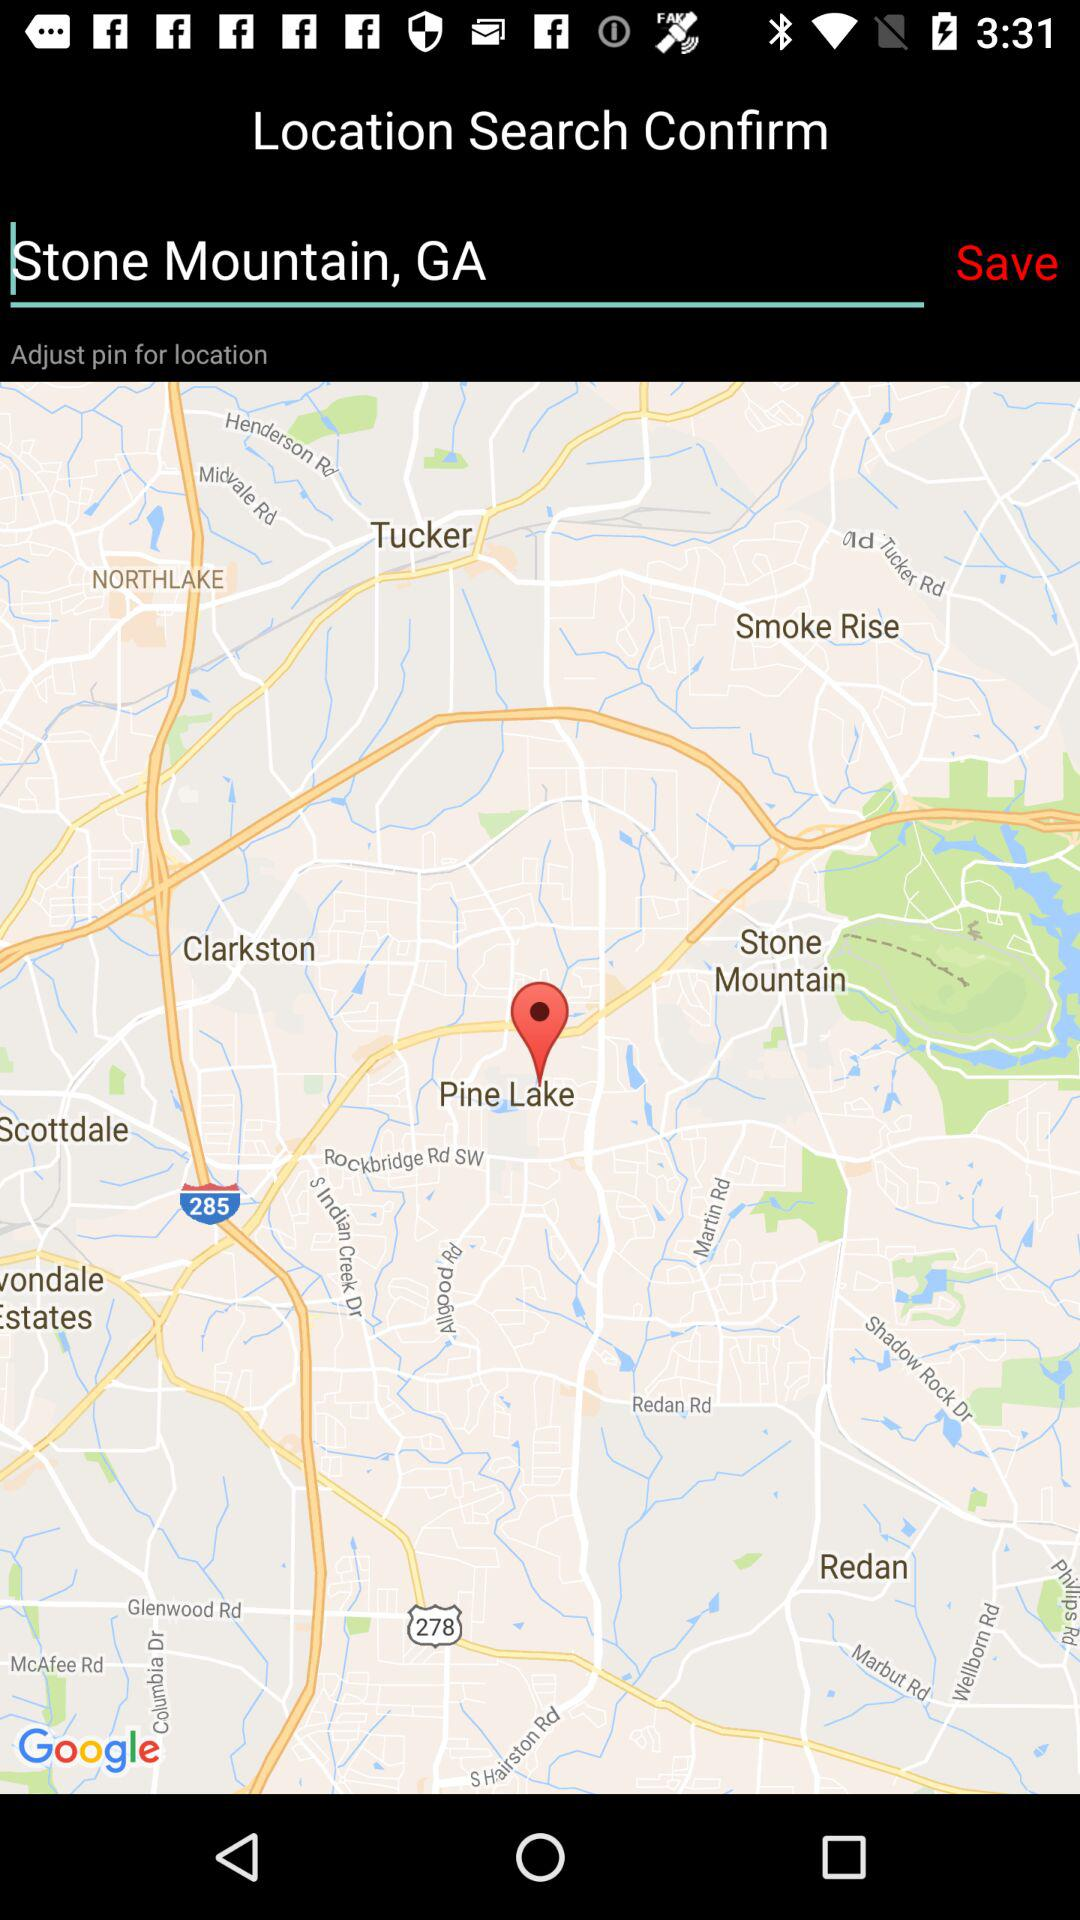What is the searched location? The searched location is Stone Mountain, GA. 